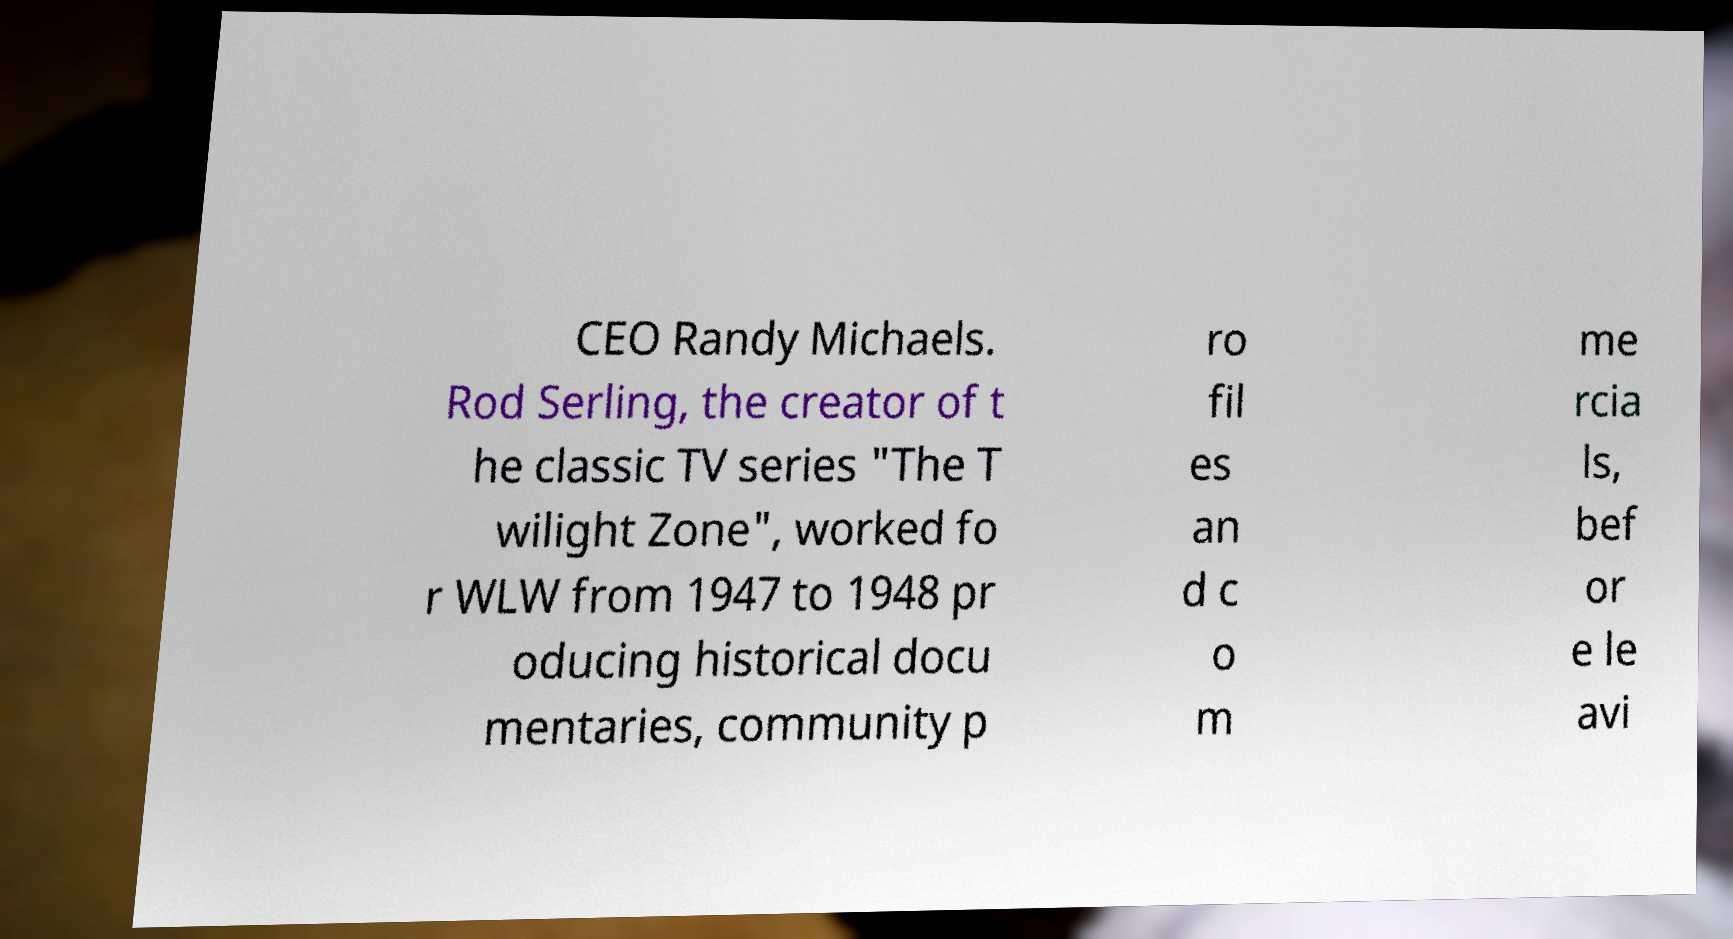Please read and relay the text visible in this image. What does it say? CEO Randy Michaels. Rod Serling, the creator of t he classic TV series "The T wilight Zone", worked fo r WLW from 1947 to 1948 pr oducing historical docu mentaries, community p ro fil es an d c o m me rcia ls, bef or e le avi 